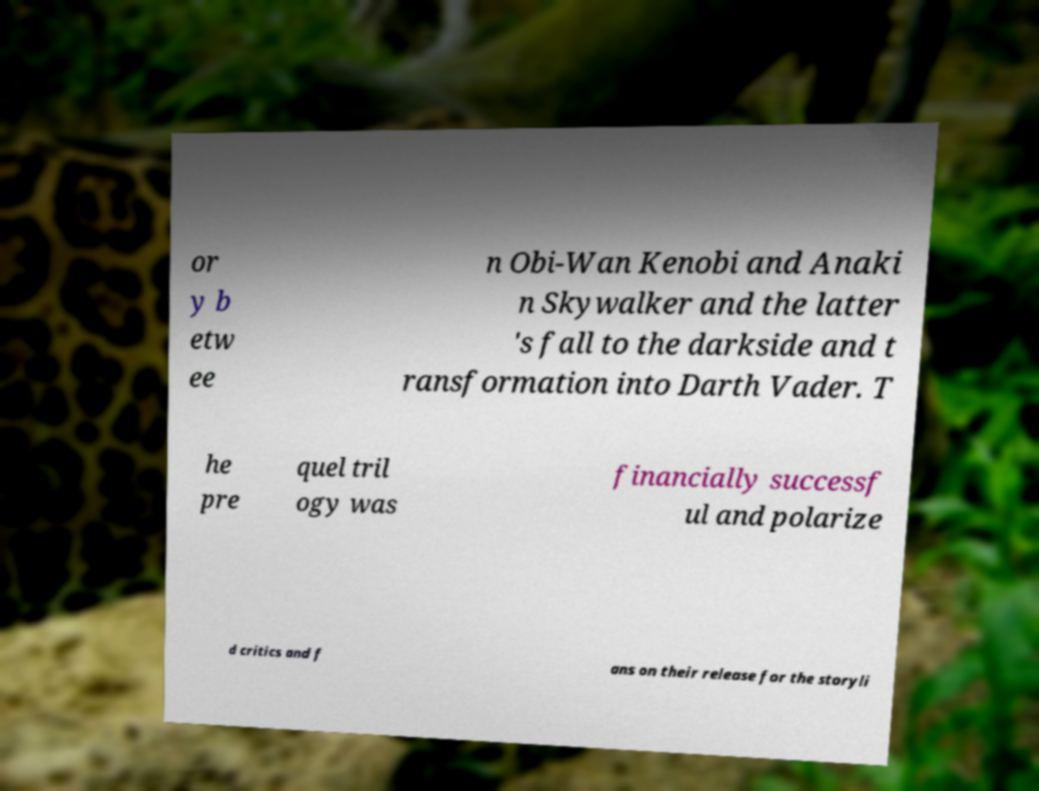Please identify and transcribe the text found in this image. or y b etw ee n Obi-Wan Kenobi and Anaki n Skywalker and the latter 's fall to the darkside and t ransformation into Darth Vader. T he pre quel tril ogy was financially successf ul and polarize d critics and f ans on their release for the storyli 